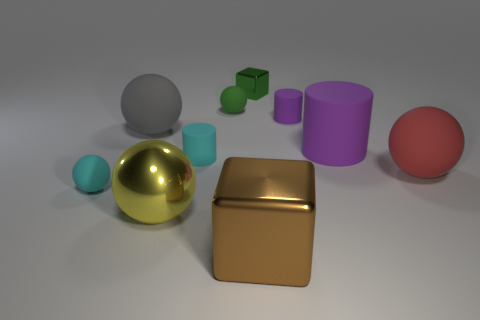Subtract all cyan balls. How many balls are left? 4 Subtract all yellow cubes. How many purple cylinders are left? 2 Subtract 1 cylinders. How many cylinders are left? 2 Subtract all green balls. How many balls are left? 4 Subtract all red cylinders. Subtract all blue blocks. How many cylinders are left? 3 Subtract all cubes. How many objects are left? 8 Add 1 brown metal blocks. How many brown metal blocks are left? 2 Add 1 large blocks. How many large blocks exist? 2 Subtract 1 gray balls. How many objects are left? 9 Subtract all yellow shiny cubes. Subtract all big red spheres. How many objects are left? 9 